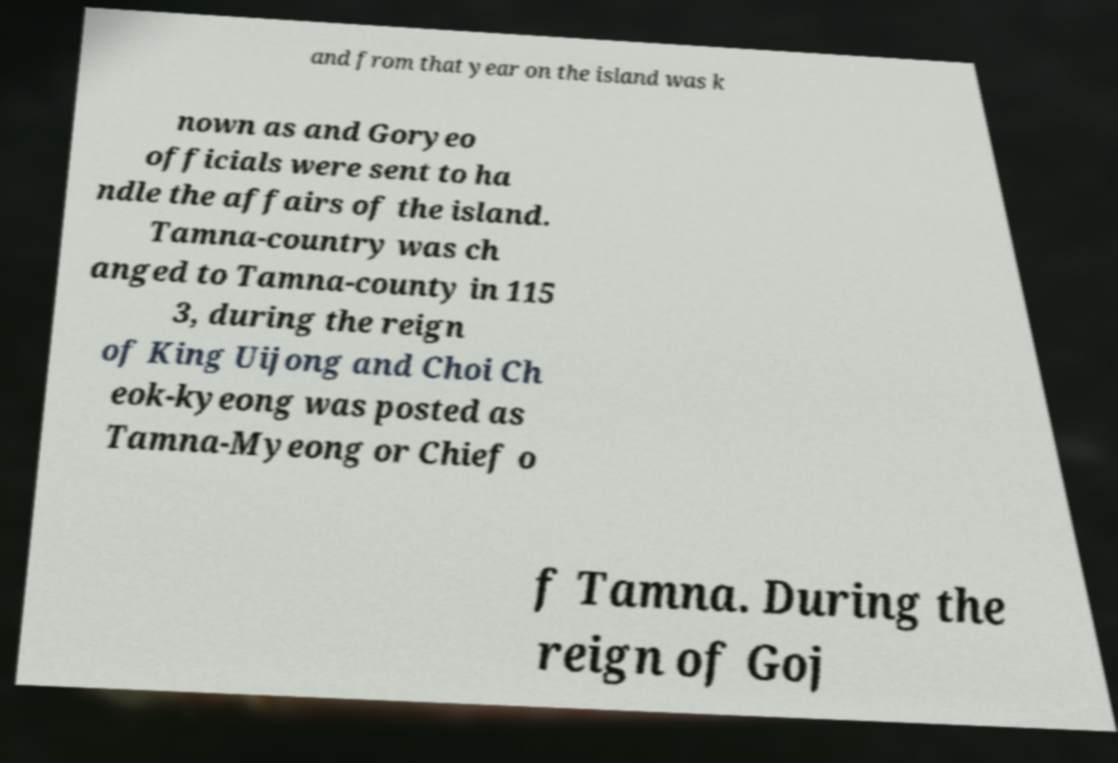Could you extract and type out the text from this image? and from that year on the island was k nown as and Goryeo officials were sent to ha ndle the affairs of the island. Tamna-country was ch anged to Tamna-county in 115 3, during the reign of King Uijong and Choi Ch eok-kyeong was posted as Tamna-Myeong or Chief o f Tamna. During the reign of Goj 